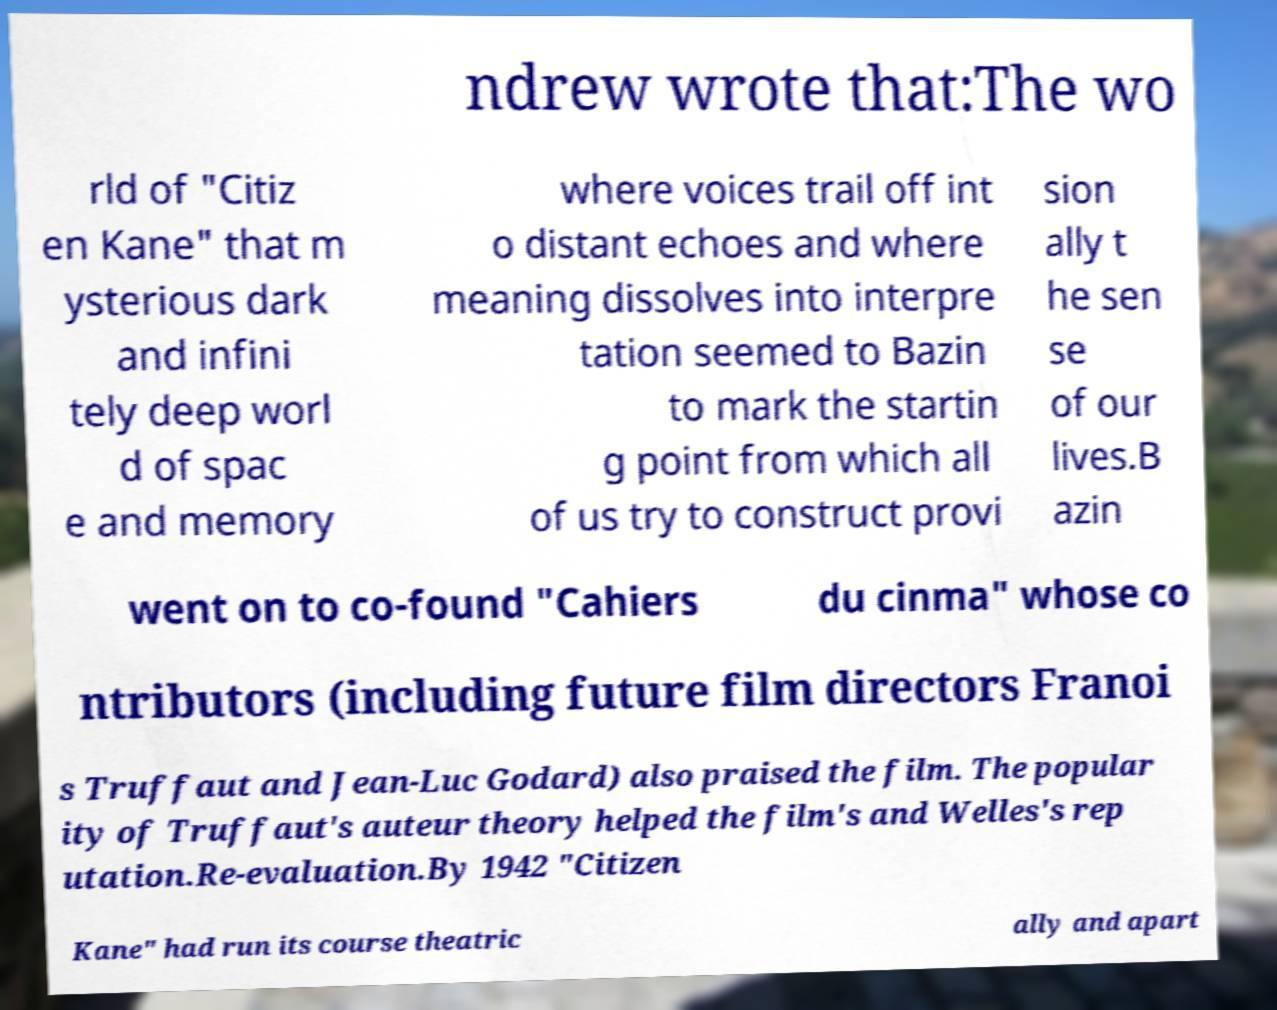There's text embedded in this image that I need extracted. Can you transcribe it verbatim? ndrew wrote that:The wo rld of "Citiz en Kane" that m ysterious dark and infini tely deep worl d of spac e and memory where voices trail off int o distant echoes and where meaning dissolves into interpre tation seemed to Bazin to mark the startin g point from which all of us try to construct provi sion ally t he sen se of our lives.B azin went on to co-found "Cahiers du cinma" whose co ntributors (including future film directors Franoi s Truffaut and Jean-Luc Godard) also praised the film. The popular ity of Truffaut's auteur theory helped the film's and Welles's rep utation.Re-evaluation.By 1942 "Citizen Kane" had run its course theatric ally and apart 